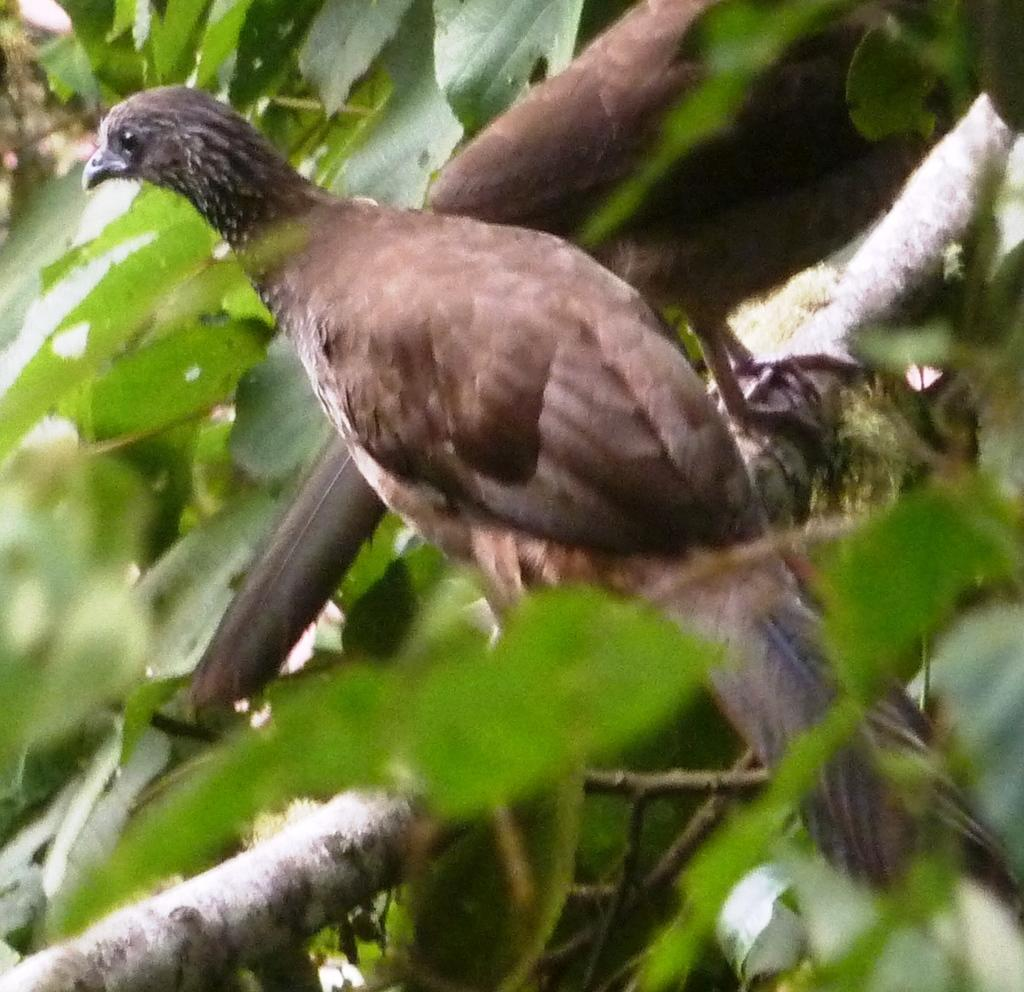How many birds are in the image? There are two birds in the image. Where are the birds located in the image? The birds are on a tree stem in the image. What else can be seen in the image besides the birds? Tree leaves are visible in the image. What type of rod is the governor using to communicate with the birds in the image? There is no governor or rod present in the image; it features two birds on a tree stem and tree leaves. 